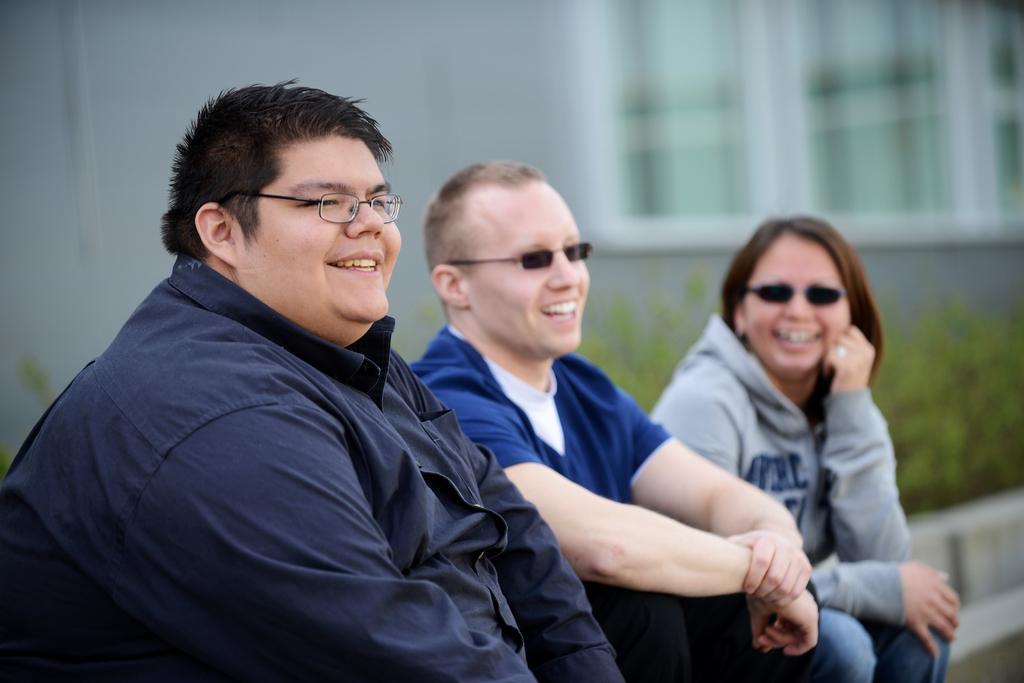Please provide a concise description of this image. This picture is clicked outside. In the center we can see the group of persons sitting. In the background we can see the wall and windows of the house and we can see the plants and some other objects. 